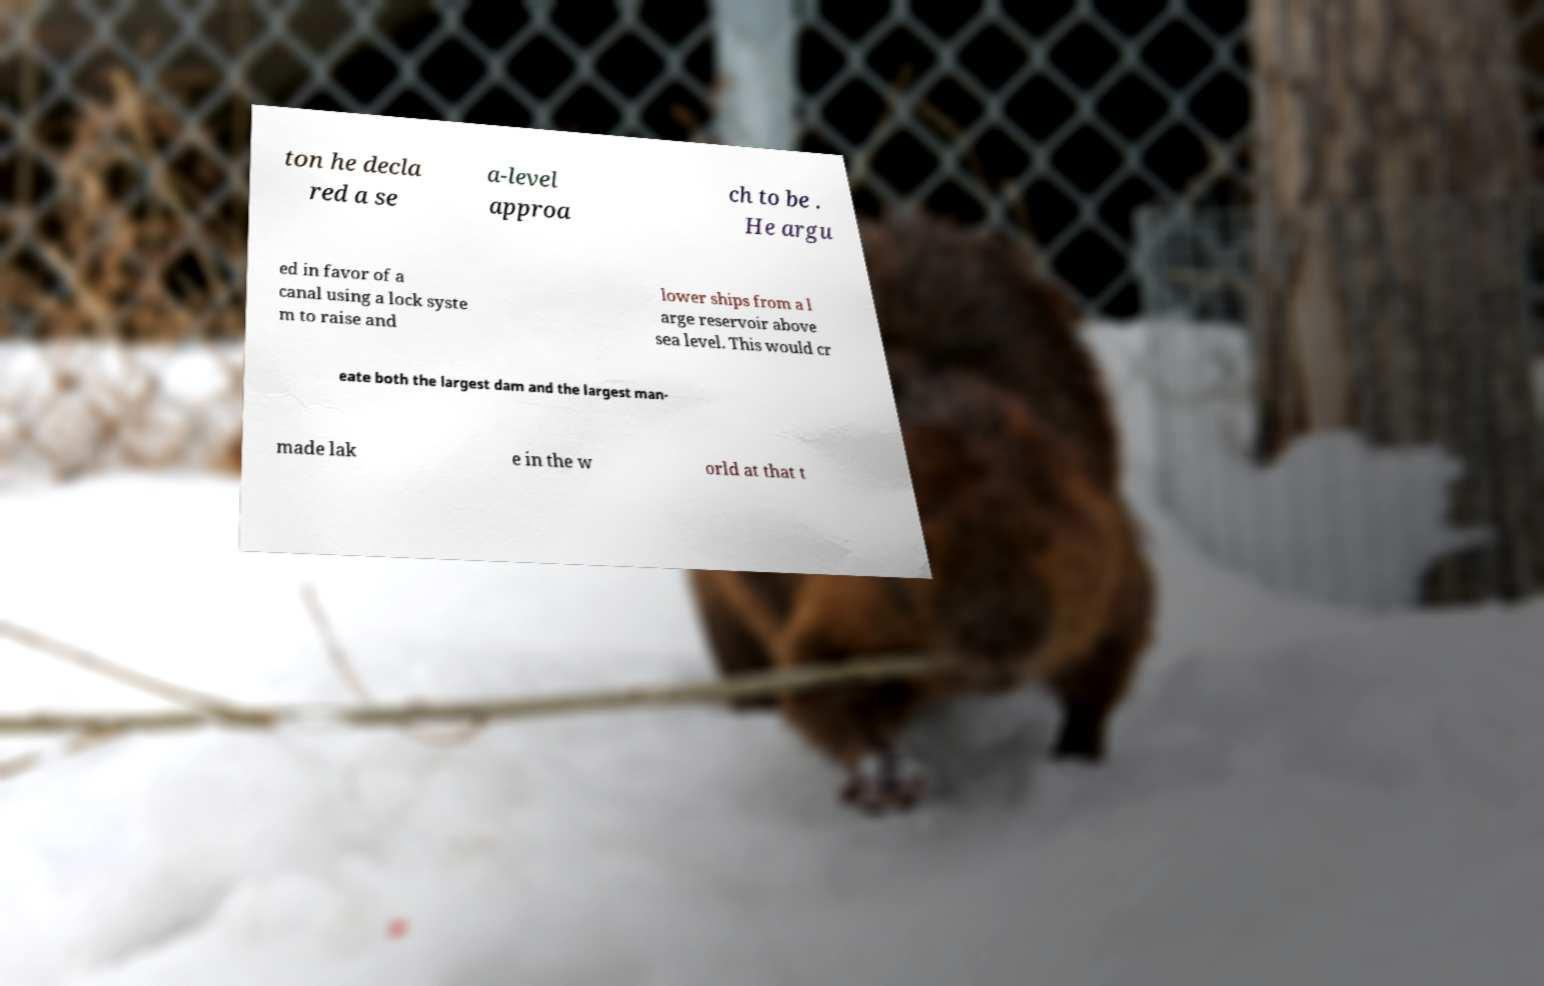For documentation purposes, I need the text within this image transcribed. Could you provide that? ton he decla red a se a-level approa ch to be . He argu ed in favor of a canal using a lock syste m to raise and lower ships from a l arge reservoir above sea level. This would cr eate both the largest dam and the largest man- made lak e in the w orld at that t 